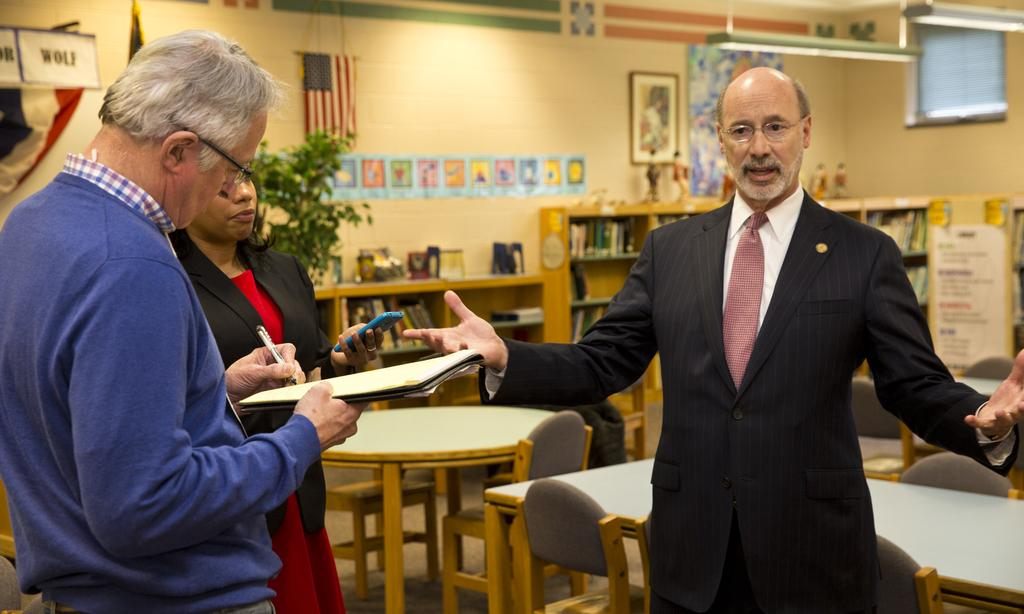How many people are in the image? There are people in the image, specifically two men and one woman. What can be seen in the background of the image? There are tables and chairs in the background of the image. What is the flag associated with in the image? The flag is present in the image, but its specific association is not clear from the facts provided. What type of object is the frame in the image? The facts provided do not specify the type of frame in the image. What type of riddle is being solved by the people in the image? There is no indication in the image that the people are solving a riddle. How many baseballs are visible in the image? There is no mention of baseballs in the image. 